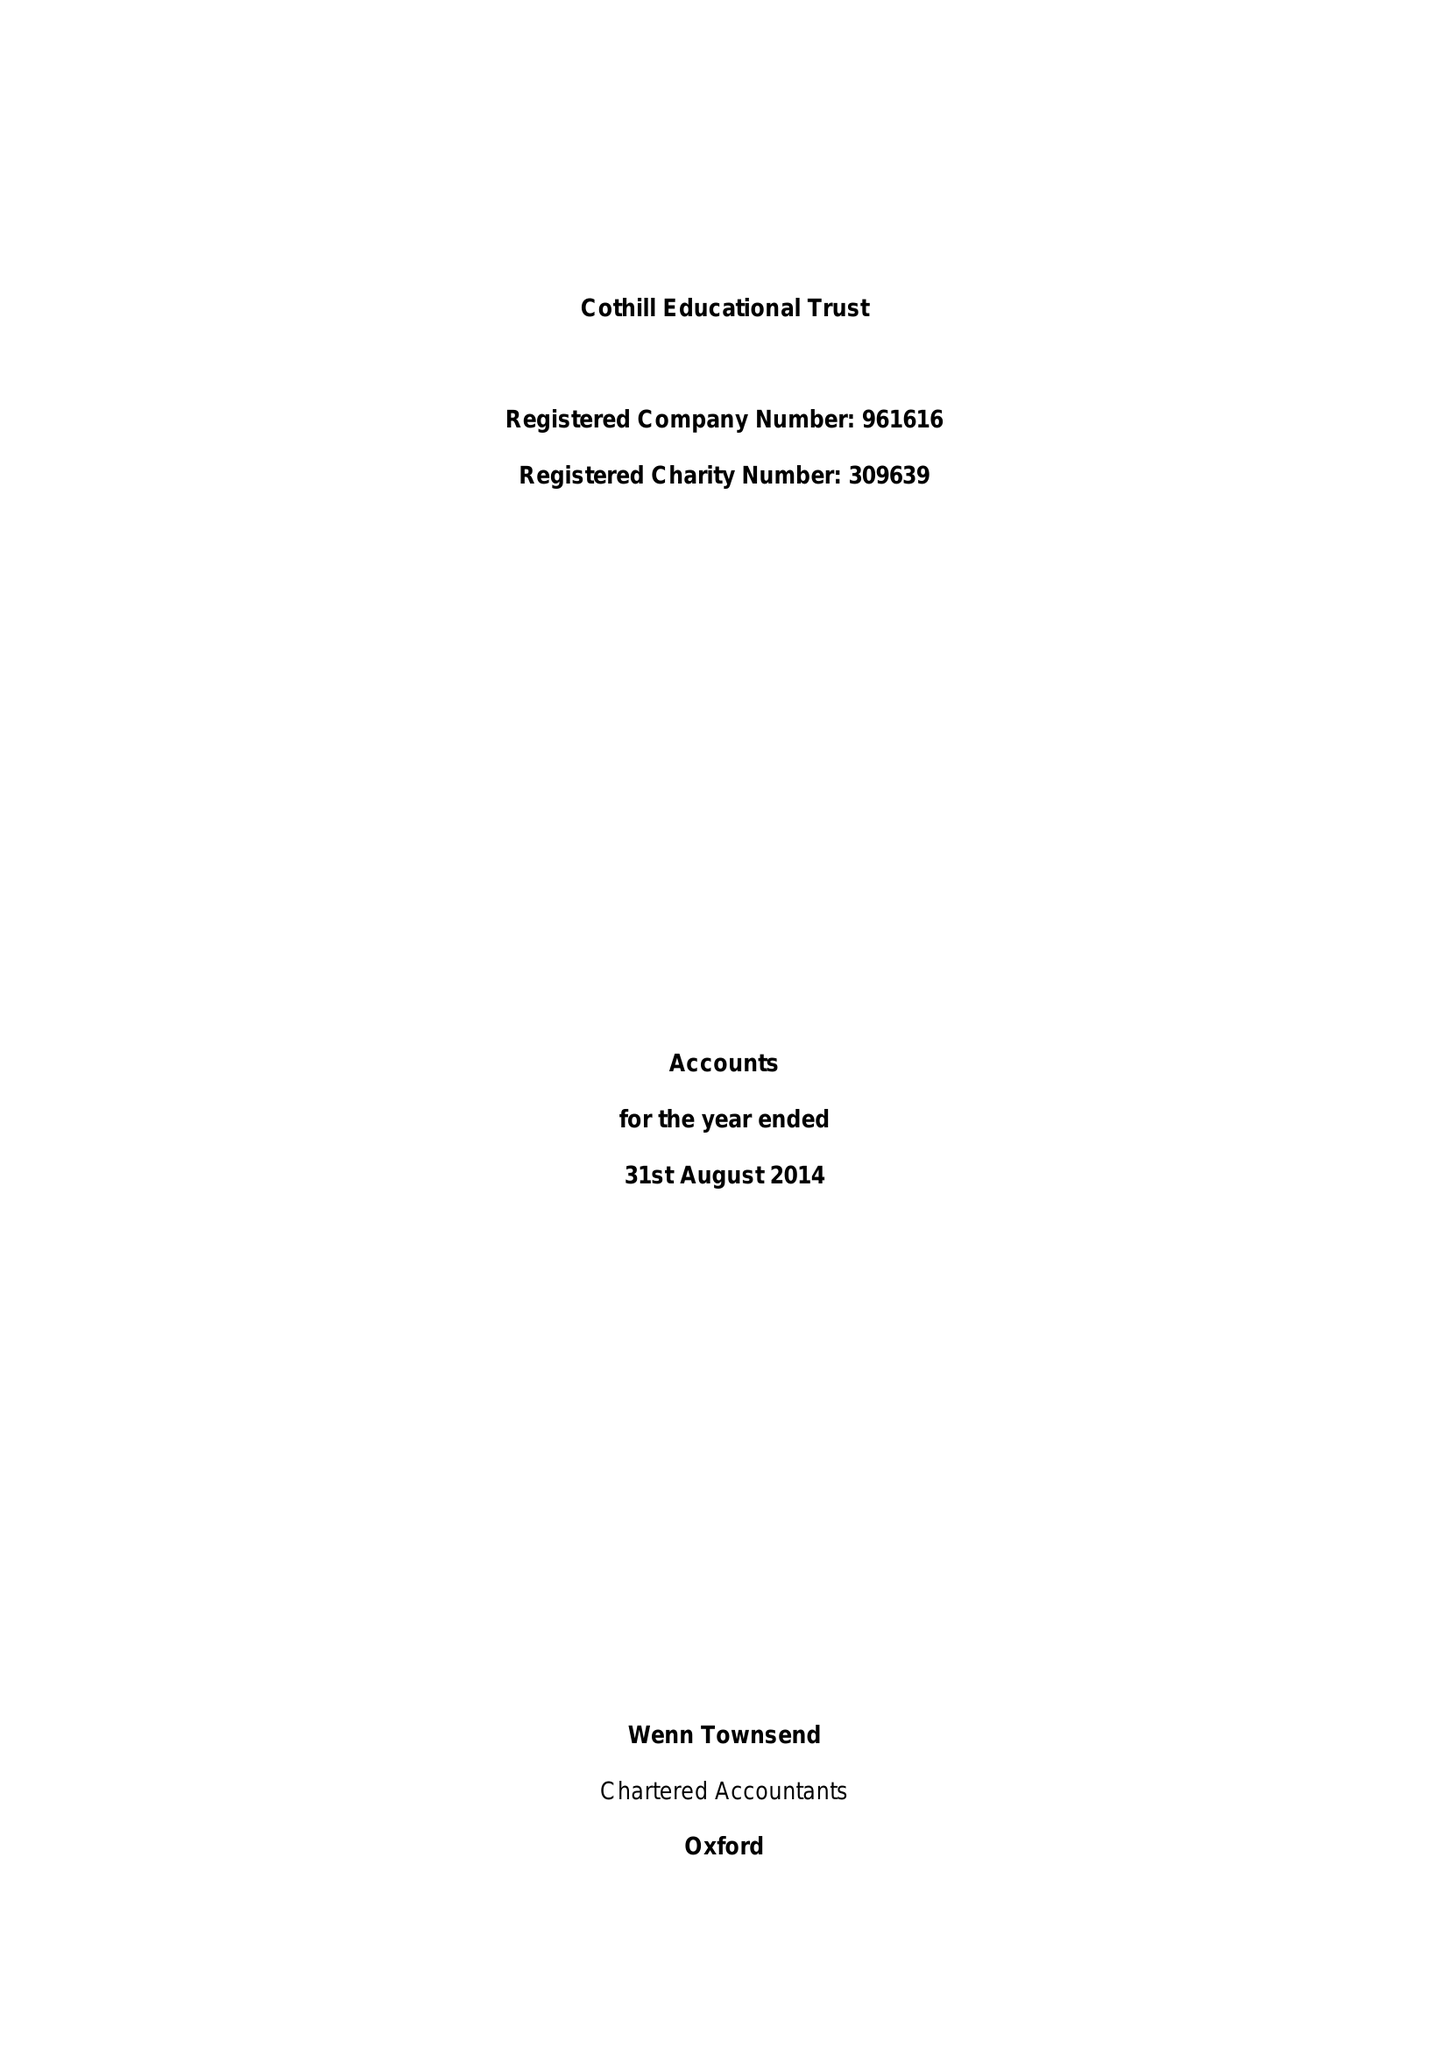What is the value for the charity_number?
Answer the question using a single word or phrase. 309639 